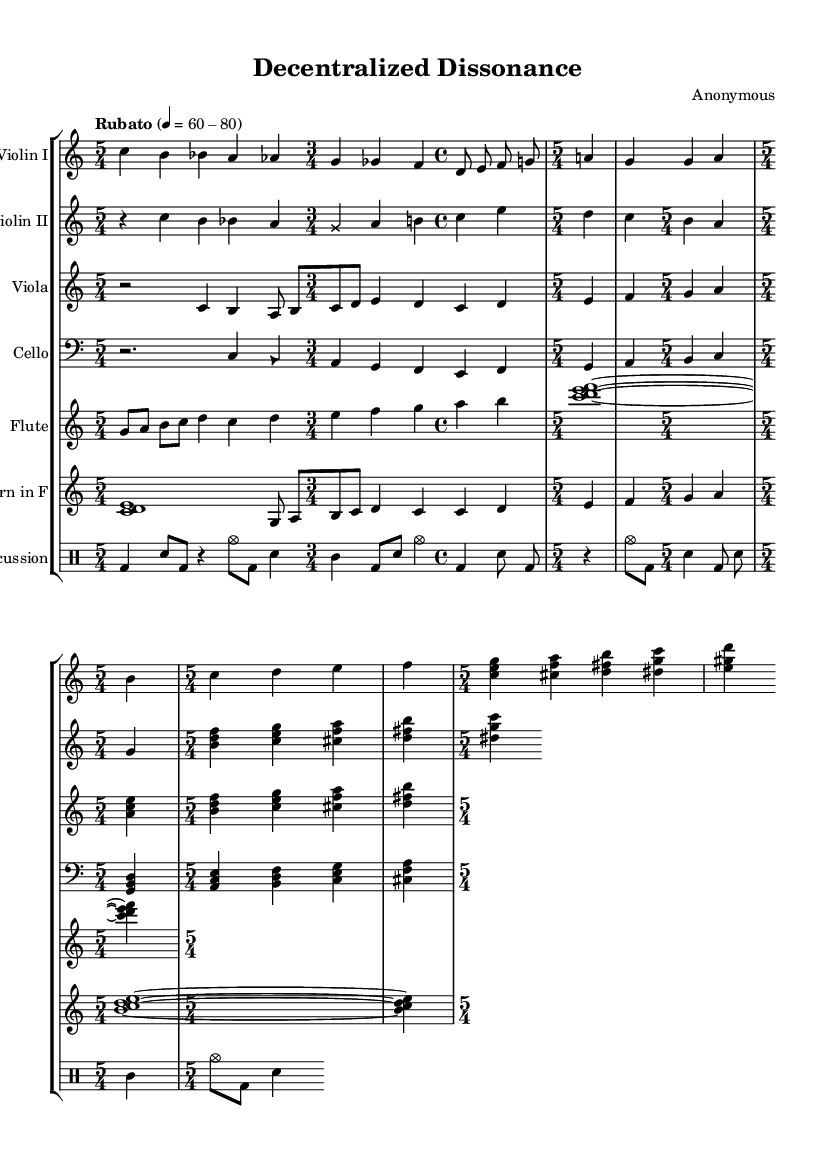What is the title of this piece? The title "Decentralized Dissonance" can be found in the header section of the sheet music.
Answer: Decentralized Dissonance What is the time signature used throughout the symphony? The time signature is primarily 5/4, as indicated in multiple sections of the music. While there are sections with other time signatures, 5/4 is a key focus.
Answer: 5/4 What is the tempo marking for this symphony? The tempo marking "Rubato" with a range of 60-80 BPM is specified in the global settings of the sheet music.
Answer: Rubato 60-80 What extended techniques are used for the violin II? The sheet music indicates an extended technique using a cross note head style for certain notes, which suggests a unique playing method.
Answer: Cross How many instruments are featured in this symphony? The score reveals that there are seven parts including two violins, viola, cello, flute, horn, and percussion, making it a chamber ensemble.
Answer: Seven What thematic element does the cello part represent? The cello part introduces the Decentralization Motif in canon form, illustrating the central theme of political decentralization within the work.
Answer: Decentralization Motif Which instrument performs a cluster chord? The flute and horn parts both feature cluster chords, indicated by the notation involving simultaneous notes being played.
Answer: Flute and Horn 